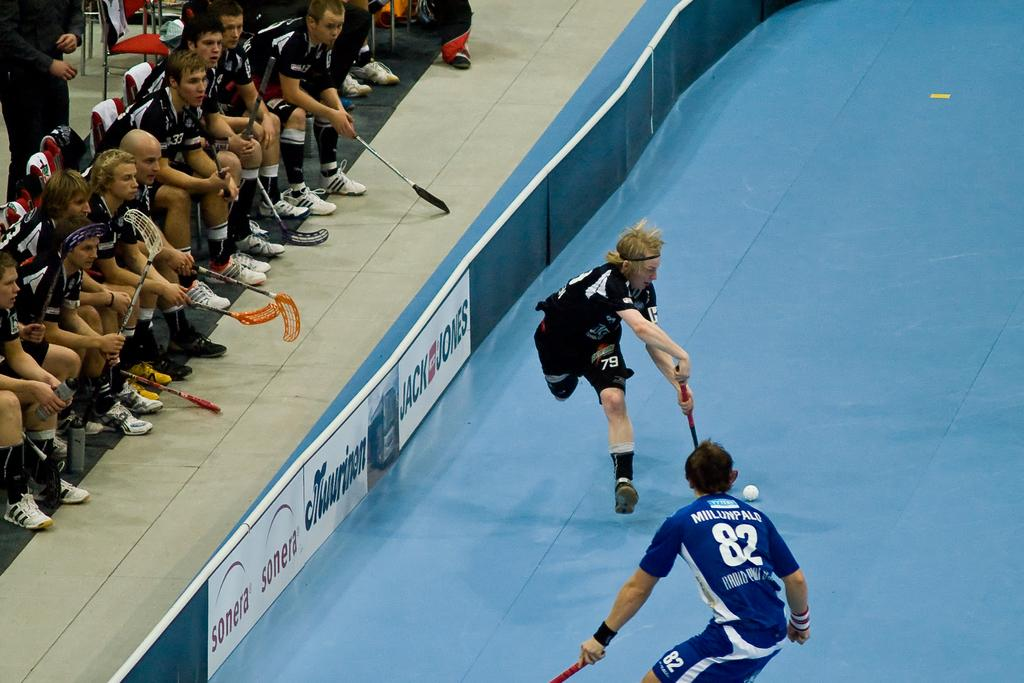How many players are actively participating in the game in the image? There are two players in the image who are actively participating in the game. What are the other players in the image doing? The other players are sitting and watching the game. Where are the other players located in the image? The other players are on the left side of the image. What is the zinc content of the game being played in the image? There is no mention of zinc or any chemical content in the image, as it depicts a game being played by two players. How does the dad feel about the game being played in the image? There is no indication of a dad or anyone's feelings about the game in the image. 